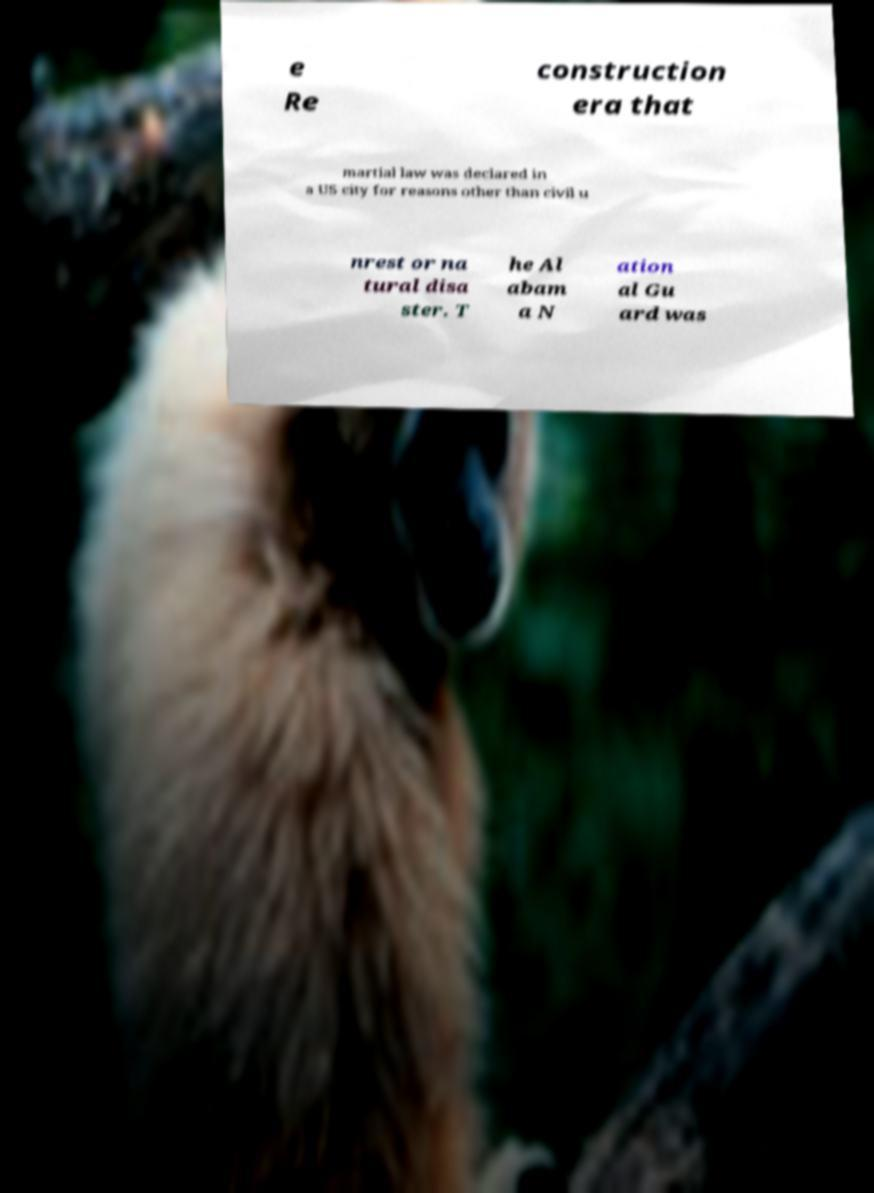Could you assist in decoding the text presented in this image and type it out clearly? e Re construction era that martial law was declared in a US city for reasons other than civil u nrest or na tural disa ster. T he Al abam a N ation al Gu ard was 